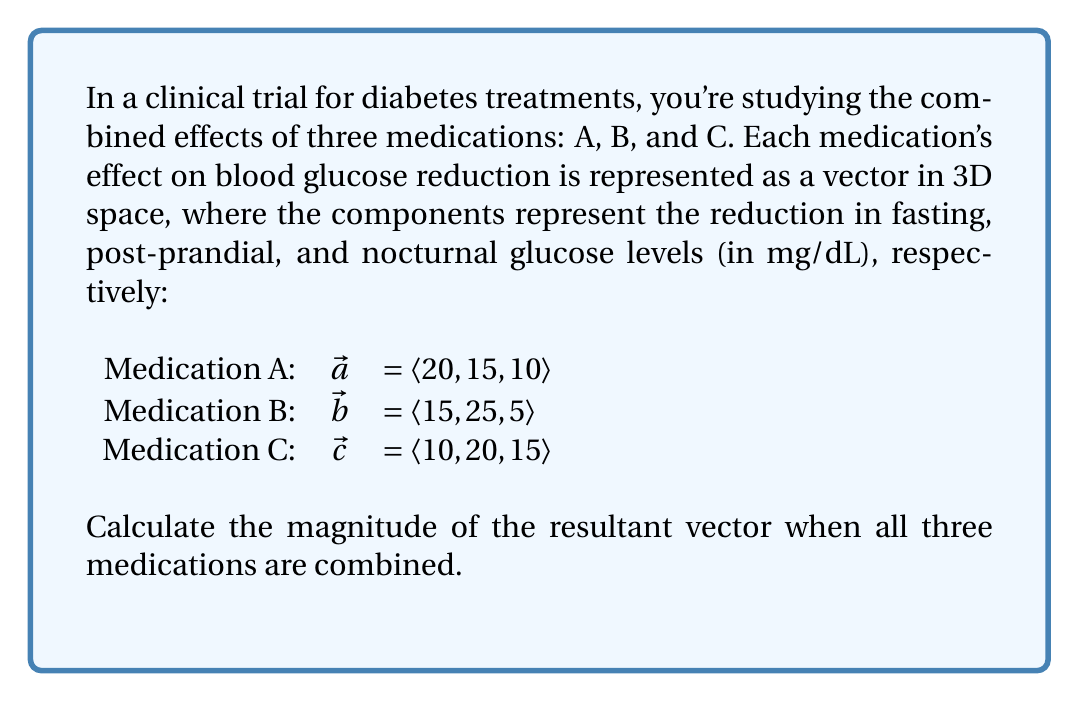Give your solution to this math problem. To solve this problem, we'll follow these steps:

1) First, we need to find the resultant vector by adding the three medication vectors:

   $\vec{r} = \vec{a} + \vec{b} + \vec{c}$
   
   $\vec{r} = \langle 20, 15, 10 \rangle + \langle 15, 25, 5 \rangle + \langle 10, 20, 15 \rangle$
   
   $\vec{r} = \langle 20+15+10, 15+25+20, 10+5+15 \rangle$
   
   $\vec{r} = \langle 45, 60, 30 \rangle$

2) Now that we have the resultant vector, we need to calculate its magnitude. The magnitude of a 3D vector $\vec{v} = \langle x, y, z \rangle$ is given by the formula:

   $|\vec{v}| = \sqrt{x^2 + y^2 + z^2}$

3) Let's substitute our values:

   $|\vec{r}| = \sqrt{45^2 + 60^2 + 30^2}$

4) Calculate:

   $|\vec{r}| = \sqrt{2025 + 3600 + 900}$
   
   $|\vec{r}| = \sqrt{6525}$
   
   $|\vec{r}| = 80.78$ (rounded to two decimal places)

Therefore, the magnitude of the resultant vector is approximately 80.78 mg/dL.
Answer: $80.78$ mg/dL 